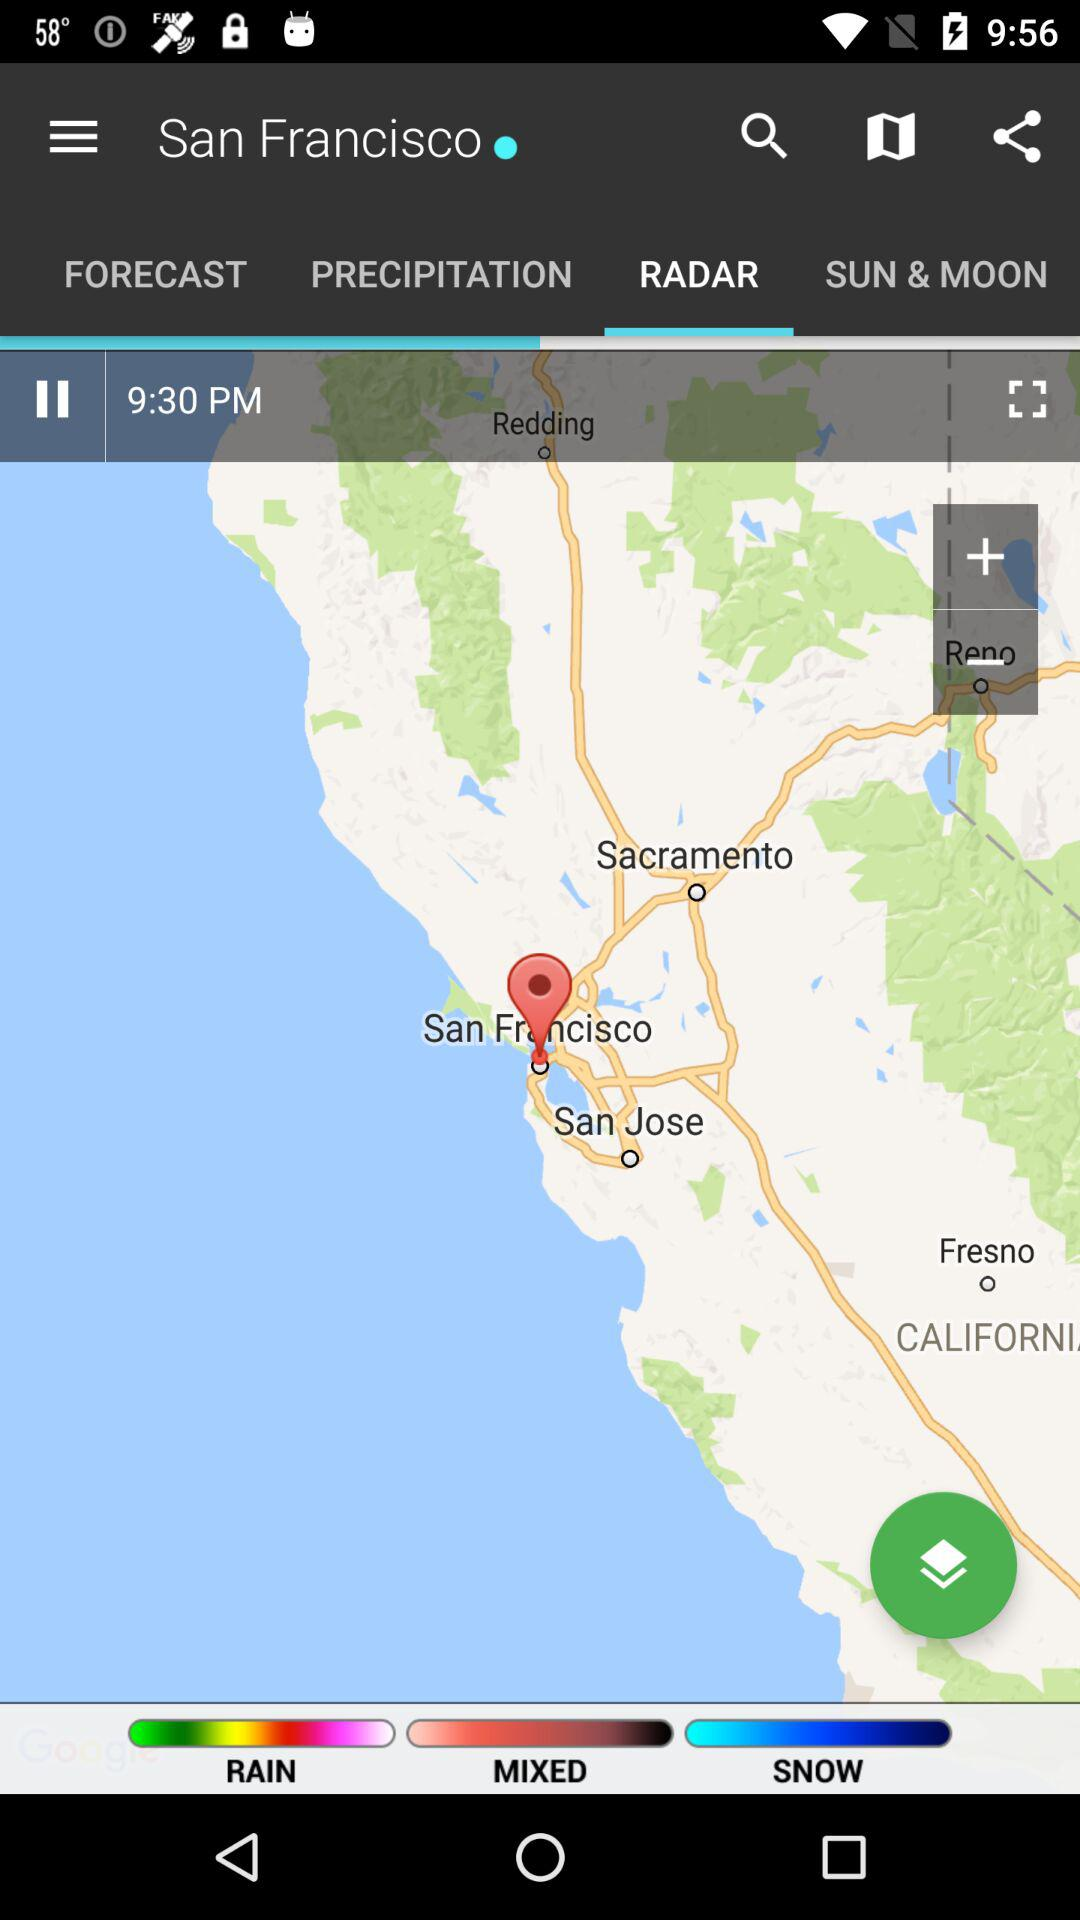How many different types of precipitation are there?
Answer the question using a single word or phrase. 3 